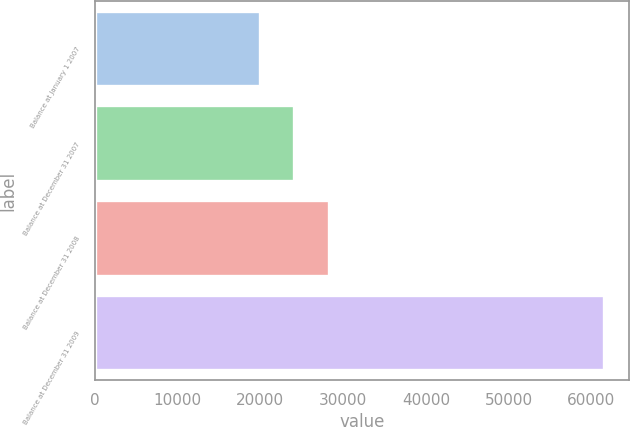<chart> <loc_0><loc_0><loc_500><loc_500><bar_chart><fcel>Balance at January 1 2007<fcel>Balance at December 31 2007<fcel>Balance at December 31 2008<fcel>Balance at December 31 2009<nl><fcel>19965.8<fcel>24118.5<fcel>28271.2<fcel>61492.6<nl></chart> 